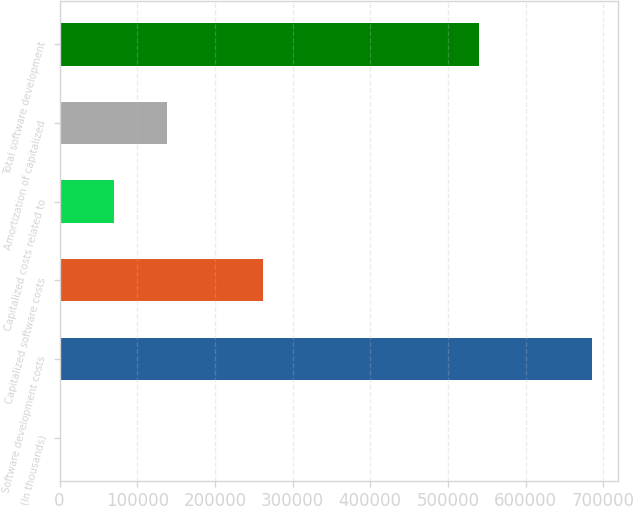Convert chart to OTSL. <chart><loc_0><loc_0><loc_500><loc_500><bar_chart><fcel>(In thousands)<fcel>Software development costs<fcel>Capitalized software costs<fcel>Capitalized costs related to<fcel>Amortization of capitalized<fcel>Total software development<nl><fcel>2015<fcel>685260<fcel>262177<fcel>70339.5<fcel>138664<fcel>539799<nl></chart> 